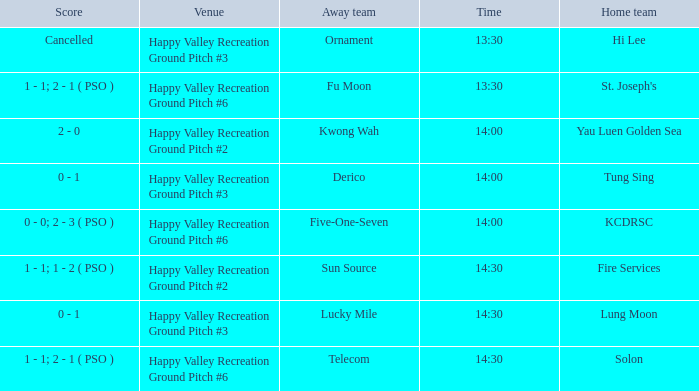What is the away team when solon was the home team? Telecom. 